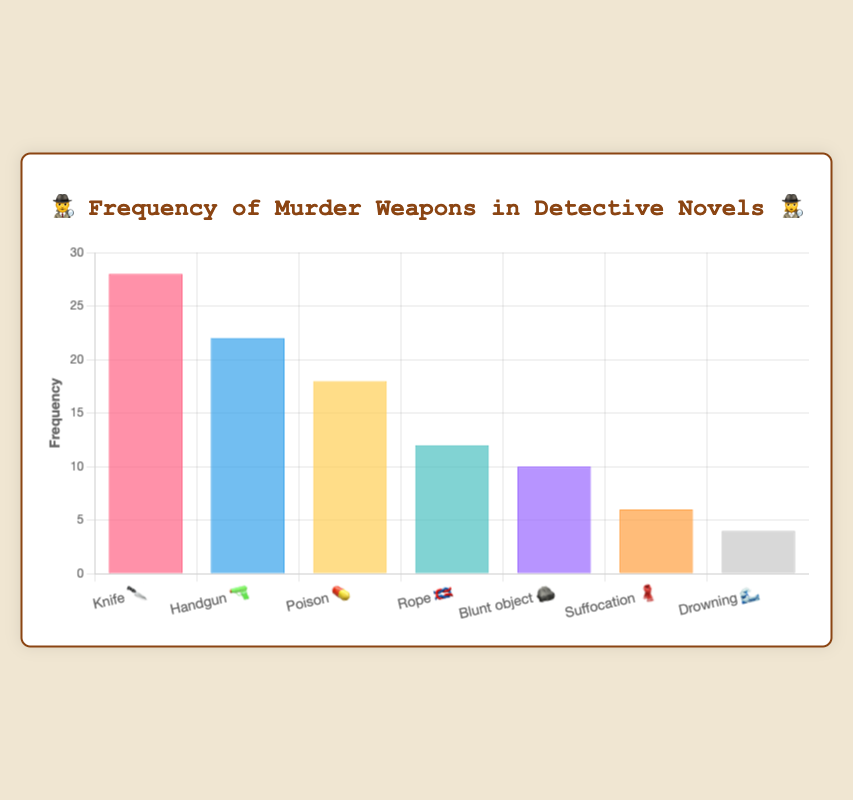Which murder weapon appears most frequently in detective novels? By referring to the bar heights, we see that the bar labeled "Knife 🔪" has the highest value at 28.
Answer: Knife 🔪 What is the frequency of the least common murder weapon? The shortest bar corresponds to "Drowning 🌊", which has a frequency of 4.
Answer: 4 How many more times is a Knife 🔪 used compared to Rope 🪢? The frequency of Knife 🔪 is 28 and Rope 🪢 is 12. The difference is 28 - 12 = 16.
Answer: 16 What is the total frequency of all the murder weapons combined? Sum the frequencies of all weapons: 28 + 22 + 18 + 12 + 10 + 6 + 4 = 100.
Answer: 100 Rank the murder weapons from most frequently used to least. By comparing the heights of the bars from highest to lowest: Knife 🔪, Handgun 🔫, Poison 💊, Rope 🪢, Blunt object 🪨, Suffocation 🧣, Drowning 🌊.
Answer: Knife 🔪 > Handgun 🔫 > Poison 💊 > Rope 🪢 > Blunt object 🪨 > Suffocation 🧣 > Drowning 🌊 What is the average frequency of murder weapons across the categories? The total frequency is 100, and there are 7 categories, so the average is 100 / 7 ≈ 14.29.
Answer: 14.29 Which weapon has a frequency closest to this average value? The average is 14.29. Comparing each frequency to this value, Rope 🪢 at 12 is closest.
Answer: Rope 🪢 How much more frequent are knives 🔪 and handguns 🔫 combined compared to poison 💊? Sum the frequencies for knives and handguns: 28 + 22 = 50. The frequency for poison is 18. The difference is 50 - 18 = 32.
Answer: 32 Are more traditional weapons (Knife 🔪, Handgun 🔫, Blunt object 🪨) used more frequently than less conventional ones (Poison 💊, Rope 🪢, Suffocation 🧣, Drowning 🌊)? Sum frequencies for traditional: 28 + 22 + 10 = 60. Sum frequencies for less conventional: 18 + 12 + 6 + 4 = 40. Traditional weapons are used more frequently.
Answer: Yes What's the median frequency of the murder weapons? The sorted frequencies are 4, 6, 10, 12, 18, 22, 28. The median is the middle value, which is 12 (Rope 🪢).
Answer: 12 